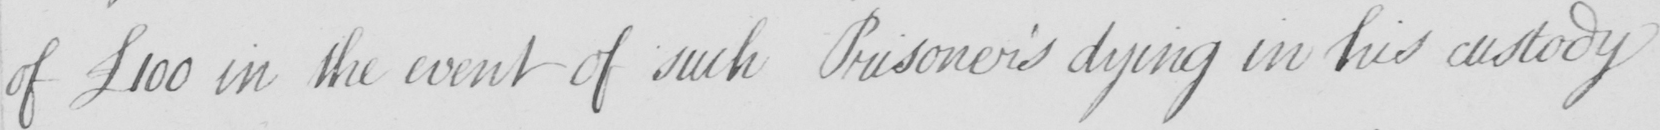What does this handwritten line say? of  £100 in the event of such Prisoner ' s dying in his custody 